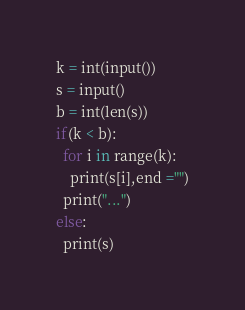<code> <loc_0><loc_0><loc_500><loc_500><_Python_>k = int(input())
s = input()
b = int(len(s)) 
if(k < b):
  for i in range(k):
    print(s[i],end ="")
  print("...")
else:
  print(s)</code> 